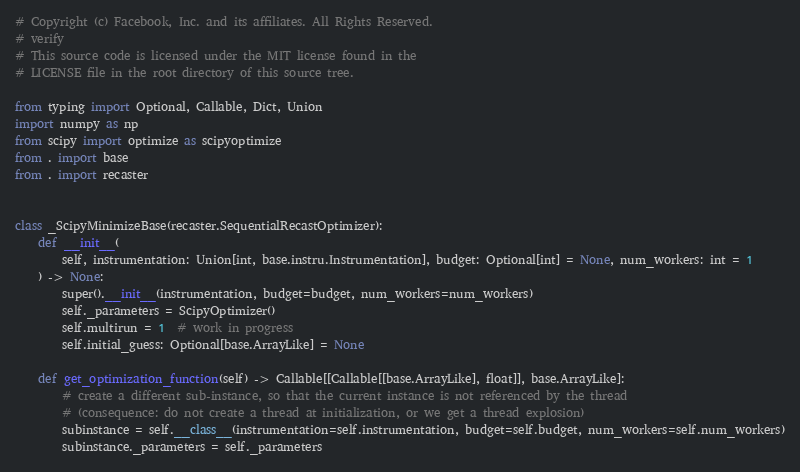Convert code to text. <code><loc_0><loc_0><loc_500><loc_500><_Python_># Copyright (c) Facebook, Inc. and its affiliates. All Rights Reserved.
# verify
# This source code is licensed under the MIT license found in the
# LICENSE file in the root directory of this source tree.

from typing import Optional, Callable, Dict, Union
import numpy as np
from scipy import optimize as scipyoptimize
from . import base
from . import recaster


class _ScipyMinimizeBase(recaster.SequentialRecastOptimizer):
    def __init__(
        self, instrumentation: Union[int, base.instru.Instrumentation], budget: Optional[int] = None, num_workers: int = 1
    ) -> None:
        super().__init__(instrumentation, budget=budget, num_workers=num_workers)
        self._parameters = ScipyOptimizer()
        self.multirun = 1  # work in progress
        self.initial_guess: Optional[base.ArrayLike] = None

    def get_optimization_function(self) -> Callable[[Callable[[base.ArrayLike], float]], base.ArrayLike]:
        # create a different sub-instance, so that the current instance is not referenced by the thread
        # (consequence: do not create a thread at initialization, or we get a thread explosion)
        subinstance = self.__class__(instrumentation=self.instrumentation, budget=self.budget, num_workers=self.num_workers)
        subinstance._parameters = self._parameters</code> 